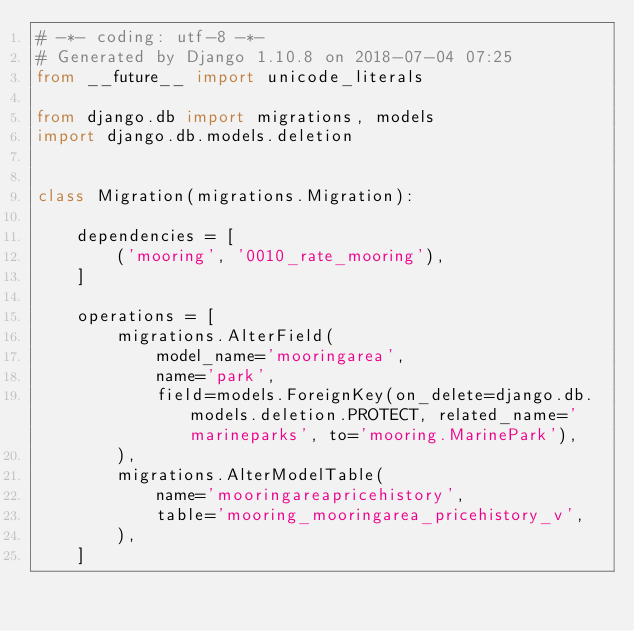Convert code to text. <code><loc_0><loc_0><loc_500><loc_500><_Python_># -*- coding: utf-8 -*-
# Generated by Django 1.10.8 on 2018-07-04 07:25
from __future__ import unicode_literals

from django.db import migrations, models
import django.db.models.deletion


class Migration(migrations.Migration):

    dependencies = [
        ('mooring', '0010_rate_mooring'),
    ]

    operations = [
        migrations.AlterField(
            model_name='mooringarea',
            name='park',
            field=models.ForeignKey(on_delete=django.db.models.deletion.PROTECT, related_name='marineparks', to='mooring.MarinePark'),
        ),
        migrations.AlterModelTable(
            name='mooringareapricehistory',
            table='mooring_mooringarea_pricehistory_v',
        ),
    ]
</code> 